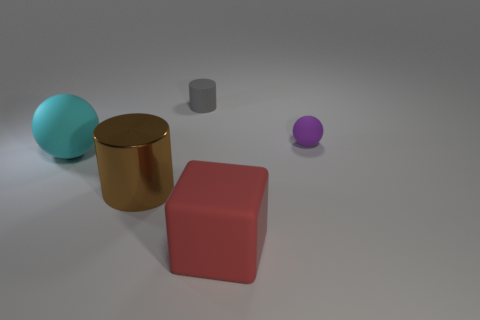Add 2 shiny things. How many objects exist? 7 Subtract all cyan balls. Subtract all yellow blocks. How many balls are left? 1 Subtract all purple cylinders. How many cyan balls are left? 1 Subtract all red cylinders. Subtract all large red cubes. How many objects are left? 4 Add 3 brown cylinders. How many brown cylinders are left? 4 Add 1 large yellow blocks. How many large yellow blocks exist? 1 Subtract all cyan balls. How many balls are left? 1 Subtract 0 green blocks. How many objects are left? 5 Subtract all cubes. How many objects are left? 4 Subtract 1 blocks. How many blocks are left? 0 